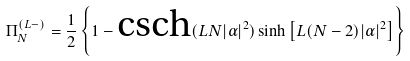Convert formula to latex. <formula><loc_0><loc_0><loc_500><loc_500>\Pi _ { N } ^ { ( L - ) } = \frac { 1 } { 2 } \left \{ 1 - \text {csch} ( L N | \alpha | ^ { 2 } ) \sinh \left [ L ( N - 2 ) | \alpha | ^ { 2 } \right ] \right \}</formula> 